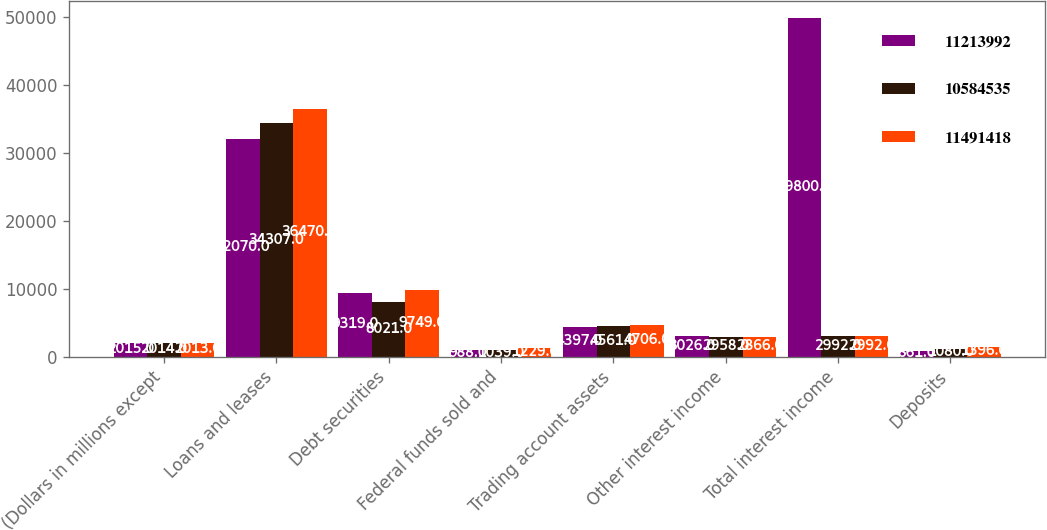Convert chart. <chart><loc_0><loc_0><loc_500><loc_500><stacked_bar_chart><ecel><fcel>(Dollars in millions except<fcel>Loans and leases<fcel>Debt securities<fcel>Federal funds sold and<fcel>Trading account assets<fcel>Other interest income<fcel>Total interest income<fcel>Deposits<nl><fcel>1.1214e+07<fcel>2015<fcel>32070<fcel>9319<fcel>988<fcel>4397<fcel>3026<fcel>49800<fcel>861<nl><fcel>1.05845e+07<fcel>2014<fcel>34307<fcel>8021<fcel>1039<fcel>4561<fcel>2958<fcel>2992<fcel>1080<nl><fcel>1.14914e+07<fcel>2013<fcel>36470<fcel>9749<fcel>1229<fcel>4706<fcel>2866<fcel>2992<fcel>1396<nl></chart> 